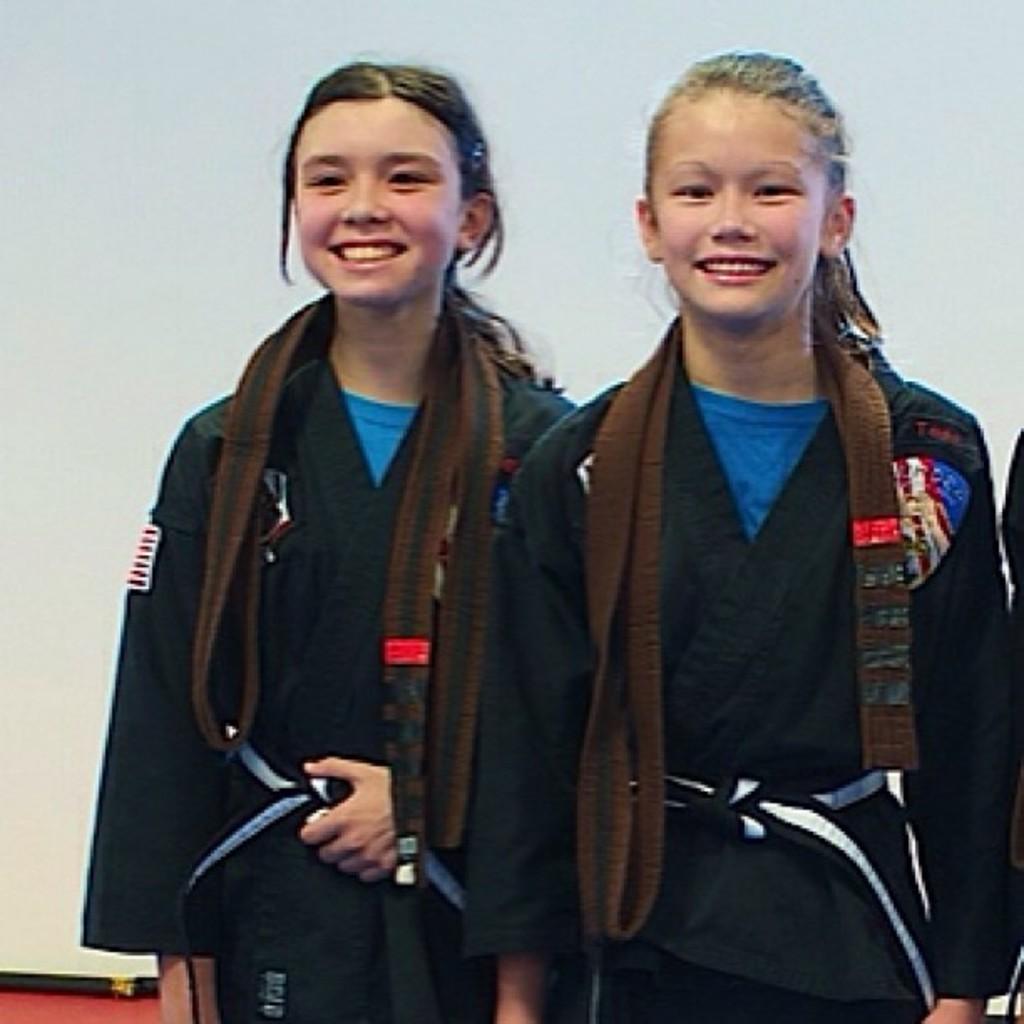How would you summarize this image in a sentence or two? There are two girls standing and smiling,behind these girls it is white. 